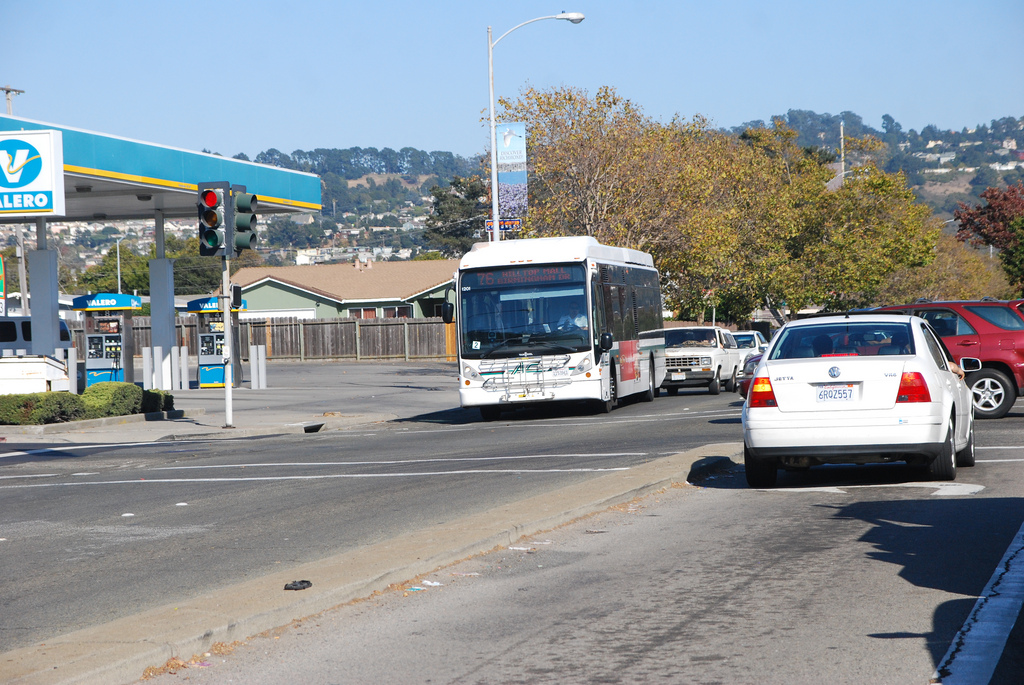Is the bus to the right or to the left of the car? The white bus, sporting a '76' advertisement, is to the left of the car, in a separate lane. 